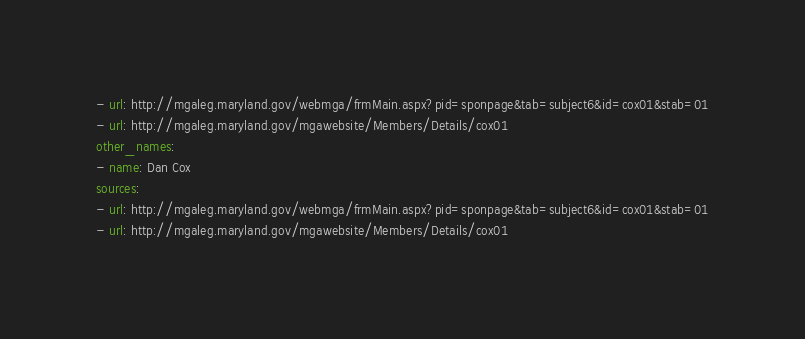<code> <loc_0><loc_0><loc_500><loc_500><_YAML_>- url: http://mgaleg.maryland.gov/webmga/frmMain.aspx?pid=sponpage&tab=subject6&id=cox01&stab=01
- url: http://mgaleg.maryland.gov/mgawebsite/Members/Details/cox01
other_names:
- name: Dan Cox
sources:
- url: http://mgaleg.maryland.gov/webmga/frmMain.aspx?pid=sponpage&tab=subject6&id=cox01&stab=01
- url: http://mgaleg.maryland.gov/mgawebsite/Members/Details/cox01
</code> 